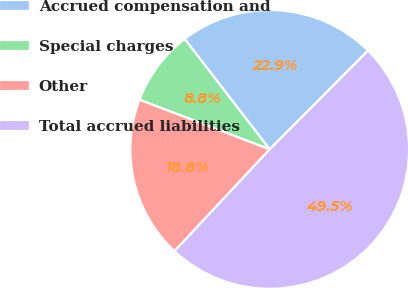<chart> <loc_0><loc_0><loc_500><loc_500><pie_chart><fcel>Accrued compensation and<fcel>Special charges<fcel>Other<fcel>Total accrued liabilities<nl><fcel>22.91%<fcel>8.76%<fcel>18.83%<fcel>49.5%<nl></chart> 